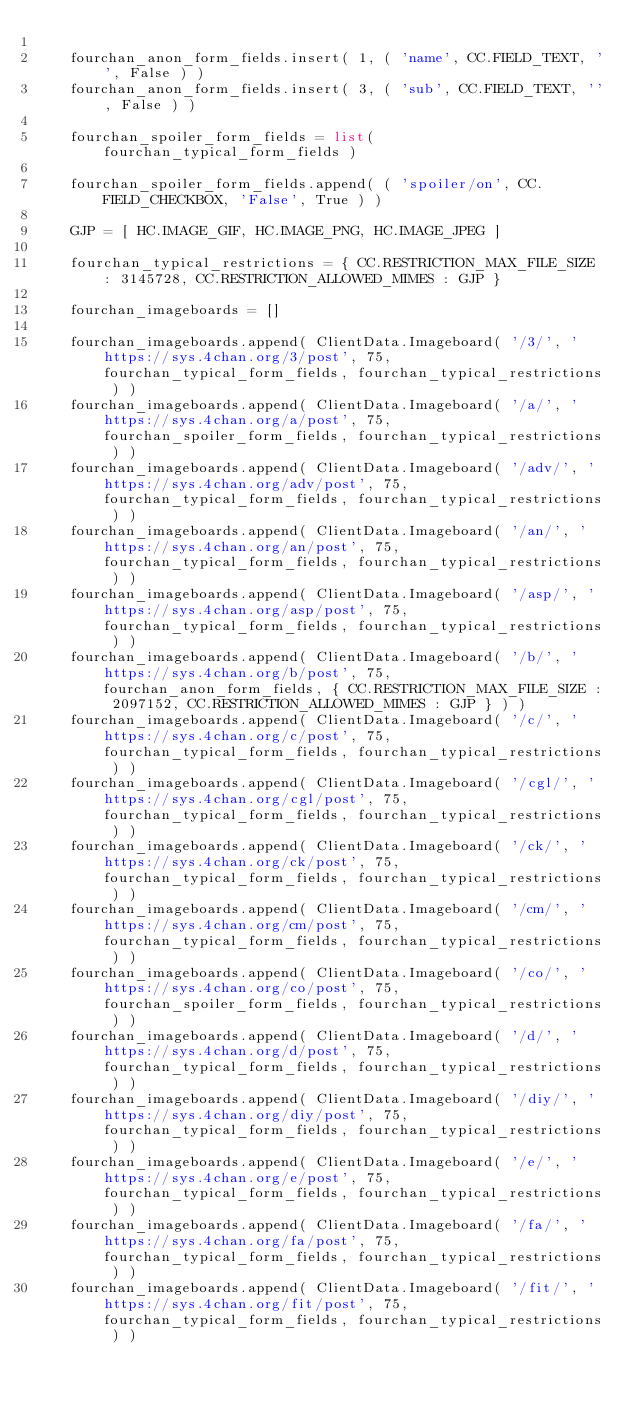<code> <loc_0><loc_0><loc_500><loc_500><_Python_>    
    fourchan_anon_form_fields.insert( 1, ( 'name', CC.FIELD_TEXT, '', False ) )
    fourchan_anon_form_fields.insert( 3, ( 'sub', CC.FIELD_TEXT, '', False ) )
    
    fourchan_spoiler_form_fields = list( fourchan_typical_form_fields )
    
    fourchan_spoiler_form_fields.append( ( 'spoiler/on', CC.FIELD_CHECKBOX, 'False', True ) )
    
    GJP = [ HC.IMAGE_GIF, HC.IMAGE_PNG, HC.IMAGE_JPEG ]
    
    fourchan_typical_restrictions = { CC.RESTRICTION_MAX_FILE_SIZE : 3145728, CC.RESTRICTION_ALLOWED_MIMES : GJP }
    
    fourchan_imageboards = []
    
    fourchan_imageboards.append( ClientData.Imageboard( '/3/', 'https://sys.4chan.org/3/post', 75, fourchan_typical_form_fields, fourchan_typical_restrictions ) )
    fourchan_imageboards.append( ClientData.Imageboard( '/a/', 'https://sys.4chan.org/a/post', 75, fourchan_spoiler_form_fields, fourchan_typical_restrictions ) )
    fourchan_imageboards.append( ClientData.Imageboard( '/adv/', 'https://sys.4chan.org/adv/post', 75, fourchan_typical_form_fields, fourchan_typical_restrictions ) )
    fourchan_imageboards.append( ClientData.Imageboard( '/an/', 'https://sys.4chan.org/an/post', 75, fourchan_typical_form_fields, fourchan_typical_restrictions ) )
    fourchan_imageboards.append( ClientData.Imageboard( '/asp/', 'https://sys.4chan.org/asp/post', 75, fourchan_typical_form_fields, fourchan_typical_restrictions ) )
    fourchan_imageboards.append( ClientData.Imageboard( '/b/', 'https://sys.4chan.org/b/post', 75, fourchan_anon_form_fields, { CC.RESTRICTION_MAX_FILE_SIZE : 2097152, CC.RESTRICTION_ALLOWED_MIMES : GJP } ) )
    fourchan_imageboards.append( ClientData.Imageboard( '/c/', 'https://sys.4chan.org/c/post', 75, fourchan_typical_form_fields, fourchan_typical_restrictions ) )
    fourchan_imageboards.append( ClientData.Imageboard( '/cgl/', 'https://sys.4chan.org/cgl/post', 75, fourchan_typical_form_fields, fourchan_typical_restrictions ) )
    fourchan_imageboards.append( ClientData.Imageboard( '/ck/', 'https://sys.4chan.org/ck/post', 75, fourchan_typical_form_fields, fourchan_typical_restrictions ) )
    fourchan_imageboards.append( ClientData.Imageboard( '/cm/', 'https://sys.4chan.org/cm/post', 75, fourchan_typical_form_fields, fourchan_typical_restrictions ) )
    fourchan_imageboards.append( ClientData.Imageboard( '/co/', 'https://sys.4chan.org/co/post', 75, fourchan_spoiler_form_fields, fourchan_typical_restrictions ) )
    fourchan_imageboards.append( ClientData.Imageboard( '/d/', 'https://sys.4chan.org/d/post', 75, fourchan_typical_form_fields, fourchan_typical_restrictions ) )
    fourchan_imageboards.append( ClientData.Imageboard( '/diy/', 'https://sys.4chan.org/diy/post', 75, fourchan_typical_form_fields, fourchan_typical_restrictions ) )
    fourchan_imageboards.append( ClientData.Imageboard( '/e/', 'https://sys.4chan.org/e/post', 75, fourchan_typical_form_fields, fourchan_typical_restrictions ) )
    fourchan_imageboards.append( ClientData.Imageboard( '/fa/', 'https://sys.4chan.org/fa/post', 75, fourchan_typical_form_fields, fourchan_typical_restrictions ) )
    fourchan_imageboards.append( ClientData.Imageboard( '/fit/', 'https://sys.4chan.org/fit/post', 75, fourchan_typical_form_fields, fourchan_typical_restrictions ) )</code> 